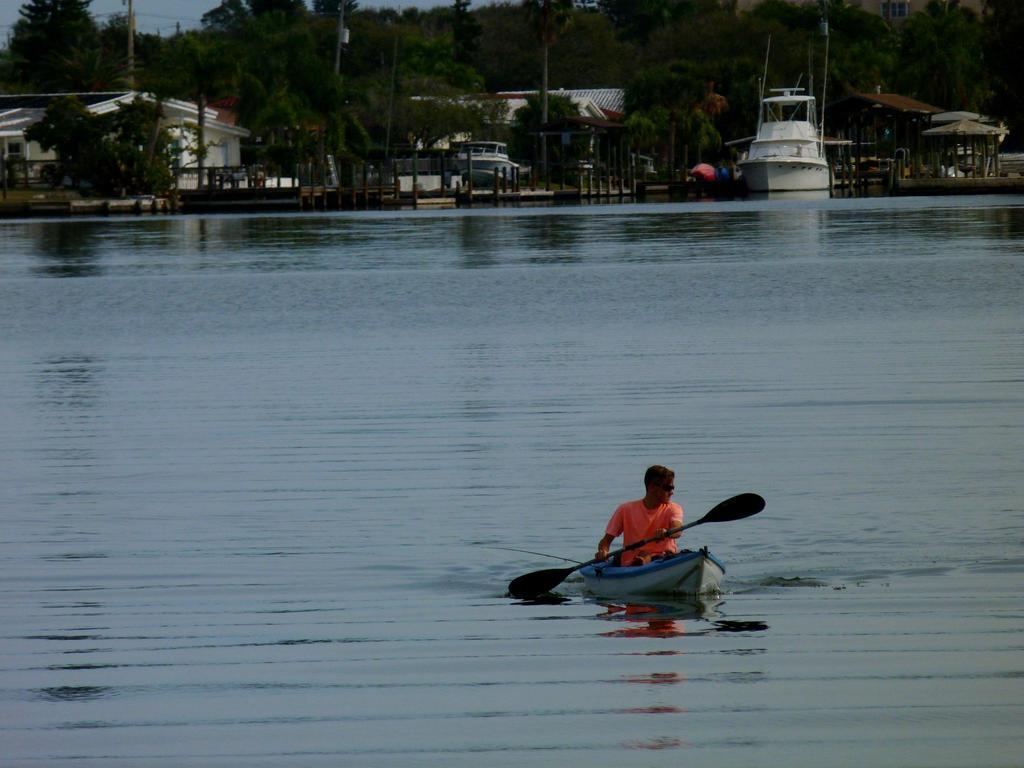What is the man in the image doing? The man is rowing a boat in the image. Where is the boat located? The boat is on the water. What can be seen in the background of the image? There are trees, boats, and buildings in the background of the image. What type of swing can be seen in the image? There is no swing present in the image; it features a man rowing a boat on the water. Can you tell me how many airplanes are flying in the image? There are no airplanes visible in the image; it only shows a man rowing a boat on the water and the background scenery. 